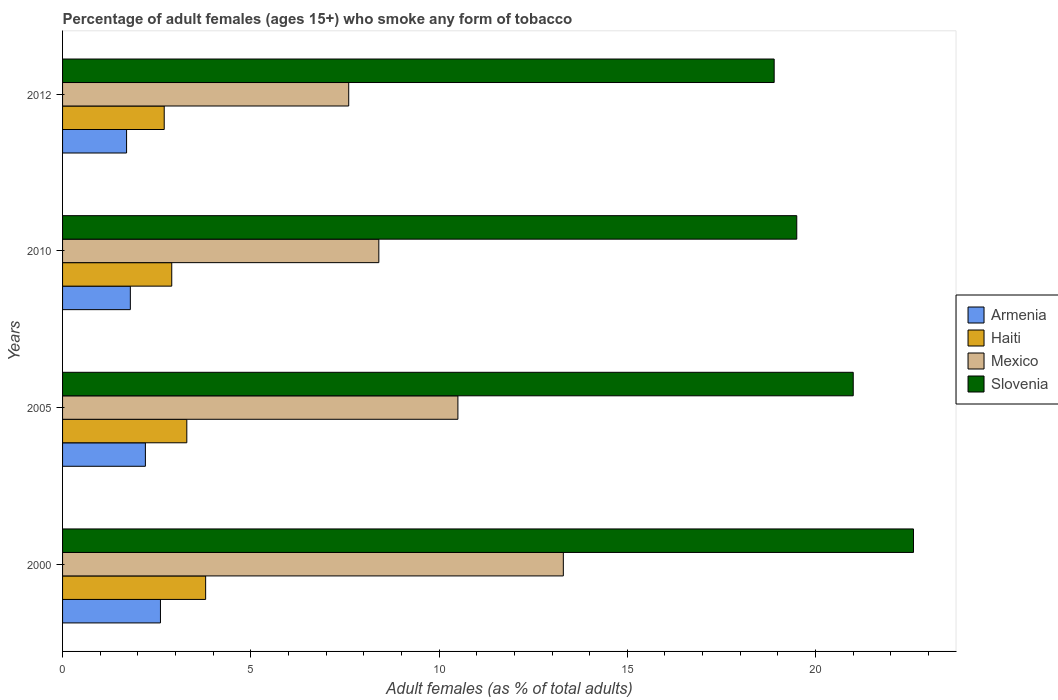How many groups of bars are there?
Provide a short and direct response. 4. How many bars are there on the 3rd tick from the top?
Offer a very short reply. 4. What is the label of the 4th group of bars from the top?
Offer a terse response. 2000. In how many cases, is the number of bars for a given year not equal to the number of legend labels?
Make the answer very short. 0. What is the percentage of adult females who smoke in Slovenia in 2005?
Ensure brevity in your answer.  21. Across all years, what is the minimum percentage of adult females who smoke in Armenia?
Provide a short and direct response. 1.7. What is the total percentage of adult females who smoke in Mexico in the graph?
Provide a short and direct response. 39.8. What is the average percentage of adult females who smoke in Armenia per year?
Offer a terse response. 2.08. In the year 2005, what is the difference between the percentage of adult females who smoke in Armenia and percentage of adult females who smoke in Haiti?
Keep it short and to the point. -1.1. What is the ratio of the percentage of adult females who smoke in Slovenia in 2000 to that in 2010?
Ensure brevity in your answer.  1.16. Is the percentage of adult females who smoke in Slovenia in 2000 less than that in 2005?
Provide a succinct answer. No. Is the difference between the percentage of adult females who smoke in Armenia in 2000 and 2005 greater than the difference between the percentage of adult females who smoke in Haiti in 2000 and 2005?
Your answer should be very brief. No. What is the difference between the highest and the second highest percentage of adult females who smoke in Armenia?
Your answer should be very brief. 0.4. What is the difference between the highest and the lowest percentage of adult females who smoke in Mexico?
Offer a terse response. 5.7. Is the sum of the percentage of adult females who smoke in Mexico in 2005 and 2012 greater than the maximum percentage of adult females who smoke in Slovenia across all years?
Offer a very short reply. No. What does the 4th bar from the top in 2012 represents?
Give a very brief answer. Armenia. Is it the case that in every year, the sum of the percentage of adult females who smoke in Haiti and percentage of adult females who smoke in Slovenia is greater than the percentage of adult females who smoke in Armenia?
Offer a terse response. Yes. How many years are there in the graph?
Make the answer very short. 4. Are the values on the major ticks of X-axis written in scientific E-notation?
Your response must be concise. No. Does the graph contain any zero values?
Offer a terse response. No. How many legend labels are there?
Keep it short and to the point. 4. What is the title of the graph?
Offer a very short reply. Percentage of adult females (ages 15+) who smoke any form of tobacco. What is the label or title of the X-axis?
Your response must be concise. Adult females (as % of total adults). What is the Adult females (as % of total adults) in Haiti in 2000?
Offer a terse response. 3.8. What is the Adult females (as % of total adults) of Mexico in 2000?
Ensure brevity in your answer.  13.3. What is the Adult females (as % of total adults) in Slovenia in 2000?
Offer a terse response. 22.6. What is the Adult females (as % of total adults) in Armenia in 2010?
Your response must be concise. 1.8. What is the Adult females (as % of total adults) in Haiti in 2010?
Ensure brevity in your answer.  2.9. What is the Adult females (as % of total adults) in Armenia in 2012?
Keep it short and to the point. 1.7. What is the Adult females (as % of total adults) in Mexico in 2012?
Your response must be concise. 7.6. What is the Adult females (as % of total adults) in Slovenia in 2012?
Give a very brief answer. 18.9. Across all years, what is the maximum Adult females (as % of total adults) of Armenia?
Make the answer very short. 2.6. Across all years, what is the maximum Adult females (as % of total adults) in Haiti?
Offer a terse response. 3.8. Across all years, what is the maximum Adult females (as % of total adults) of Slovenia?
Your response must be concise. 22.6. Across all years, what is the minimum Adult females (as % of total adults) in Haiti?
Provide a succinct answer. 2.7. Across all years, what is the minimum Adult females (as % of total adults) in Mexico?
Offer a terse response. 7.6. What is the total Adult females (as % of total adults) in Armenia in the graph?
Keep it short and to the point. 8.3. What is the total Adult females (as % of total adults) in Haiti in the graph?
Give a very brief answer. 12.7. What is the total Adult females (as % of total adults) of Mexico in the graph?
Keep it short and to the point. 39.8. What is the total Adult females (as % of total adults) of Slovenia in the graph?
Your answer should be compact. 82. What is the difference between the Adult females (as % of total adults) in Slovenia in 2000 and that in 2005?
Make the answer very short. 1.6. What is the difference between the Adult females (as % of total adults) of Haiti in 2000 and that in 2010?
Offer a very short reply. 0.9. What is the difference between the Adult females (as % of total adults) of Mexico in 2000 and that in 2010?
Keep it short and to the point. 4.9. What is the difference between the Adult females (as % of total adults) in Slovenia in 2000 and that in 2010?
Offer a very short reply. 3.1. What is the difference between the Adult females (as % of total adults) in Slovenia in 2000 and that in 2012?
Provide a short and direct response. 3.7. What is the difference between the Adult females (as % of total adults) of Armenia in 2005 and that in 2010?
Your answer should be very brief. 0.4. What is the difference between the Adult females (as % of total adults) of Slovenia in 2005 and that in 2010?
Offer a terse response. 1.5. What is the difference between the Adult females (as % of total adults) in Haiti in 2005 and that in 2012?
Your answer should be compact. 0.6. What is the difference between the Adult females (as % of total adults) of Armenia in 2010 and that in 2012?
Give a very brief answer. 0.1. What is the difference between the Adult females (as % of total adults) of Haiti in 2010 and that in 2012?
Your answer should be very brief. 0.2. What is the difference between the Adult females (as % of total adults) of Slovenia in 2010 and that in 2012?
Provide a succinct answer. 0.6. What is the difference between the Adult females (as % of total adults) in Armenia in 2000 and the Adult females (as % of total adults) in Haiti in 2005?
Make the answer very short. -0.7. What is the difference between the Adult females (as % of total adults) of Armenia in 2000 and the Adult females (as % of total adults) of Mexico in 2005?
Your answer should be very brief. -7.9. What is the difference between the Adult females (as % of total adults) of Armenia in 2000 and the Adult females (as % of total adults) of Slovenia in 2005?
Offer a very short reply. -18.4. What is the difference between the Adult females (as % of total adults) of Haiti in 2000 and the Adult females (as % of total adults) of Mexico in 2005?
Keep it short and to the point. -6.7. What is the difference between the Adult females (as % of total adults) of Haiti in 2000 and the Adult females (as % of total adults) of Slovenia in 2005?
Make the answer very short. -17.2. What is the difference between the Adult females (as % of total adults) of Mexico in 2000 and the Adult females (as % of total adults) of Slovenia in 2005?
Offer a terse response. -7.7. What is the difference between the Adult females (as % of total adults) in Armenia in 2000 and the Adult females (as % of total adults) in Slovenia in 2010?
Your response must be concise. -16.9. What is the difference between the Adult females (as % of total adults) of Haiti in 2000 and the Adult females (as % of total adults) of Slovenia in 2010?
Provide a succinct answer. -15.7. What is the difference between the Adult females (as % of total adults) in Armenia in 2000 and the Adult females (as % of total adults) in Slovenia in 2012?
Ensure brevity in your answer.  -16.3. What is the difference between the Adult females (as % of total adults) in Haiti in 2000 and the Adult females (as % of total adults) in Mexico in 2012?
Ensure brevity in your answer.  -3.8. What is the difference between the Adult females (as % of total adults) in Haiti in 2000 and the Adult females (as % of total adults) in Slovenia in 2012?
Offer a very short reply. -15.1. What is the difference between the Adult females (as % of total adults) of Mexico in 2000 and the Adult females (as % of total adults) of Slovenia in 2012?
Provide a short and direct response. -5.6. What is the difference between the Adult females (as % of total adults) of Armenia in 2005 and the Adult females (as % of total adults) of Mexico in 2010?
Offer a very short reply. -6.2. What is the difference between the Adult females (as % of total adults) of Armenia in 2005 and the Adult females (as % of total adults) of Slovenia in 2010?
Your response must be concise. -17.3. What is the difference between the Adult females (as % of total adults) of Haiti in 2005 and the Adult females (as % of total adults) of Mexico in 2010?
Ensure brevity in your answer.  -5.1. What is the difference between the Adult females (as % of total adults) of Haiti in 2005 and the Adult females (as % of total adults) of Slovenia in 2010?
Offer a very short reply. -16.2. What is the difference between the Adult females (as % of total adults) of Armenia in 2005 and the Adult females (as % of total adults) of Haiti in 2012?
Provide a short and direct response. -0.5. What is the difference between the Adult females (as % of total adults) in Armenia in 2005 and the Adult females (as % of total adults) in Slovenia in 2012?
Your answer should be very brief. -16.7. What is the difference between the Adult females (as % of total adults) of Haiti in 2005 and the Adult females (as % of total adults) of Slovenia in 2012?
Offer a very short reply. -15.6. What is the difference between the Adult females (as % of total adults) in Mexico in 2005 and the Adult females (as % of total adults) in Slovenia in 2012?
Your response must be concise. -8.4. What is the difference between the Adult females (as % of total adults) of Armenia in 2010 and the Adult females (as % of total adults) of Mexico in 2012?
Your answer should be compact. -5.8. What is the difference between the Adult females (as % of total adults) of Armenia in 2010 and the Adult females (as % of total adults) of Slovenia in 2012?
Your response must be concise. -17.1. What is the average Adult females (as % of total adults) in Armenia per year?
Your answer should be very brief. 2.08. What is the average Adult females (as % of total adults) of Haiti per year?
Make the answer very short. 3.17. What is the average Adult females (as % of total adults) of Mexico per year?
Your response must be concise. 9.95. What is the average Adult females (as % of total adults) in Slovenia per year?
Provide a succinct answer. 20.5. In the year 2000, what is the difference between the Adult females (as % of total adults) in Armenia and Adult females (as % of total adults) in Slovenia?
Your response must be concise. -20. In the year 2000, what is the difference between the Adult females (as % of total adults) of Haiti and Adult females (as % of total adults) of Slovenia?
Your answer should be compact. -18.8. In the year 2005, what is the difference between the Adult females (as % of total adults) in Armenia and Adult females (as % of total adults) in Haiti?
Make the answer very short. -1.1. In the year 2005, what is the difference between the Adult females (as % of total adults) in Armenia and Adult females (as % of total adults) in Slovenia?
Offer a terse response. -18.8. In the year 2005, what is the difference between the Adult females (as % of total adults) of Haiti and Adult females (as % of total adults) of Slovenia?
Your response must be concise. -17.7. In the year 2005, what is the difference between the Adult females (as % of total adults) in Mexico and Adult females (as % of total adults) in Slovenia?
Provide a succinct answer. -10.5. In the year 2010, what is the difference between the Adult females (as % of total adults) in Armenia and Adult females (as % of total adults) in Mexico?
Provide a short and direct response. -6.6. In the year 2010, what is the difference between the Adult females (as % of total adults) in Armenia and Adult females (as % of total adults) in Slovenia?
Provide a short and direct response. -17.7. In the year 2010, what is the difference between the Adult females (as % of total adults) of Haiti and Adult females (as % of total adults) of Mexico?
Give a very brief answer. -5.5. In the year 2010, what is the difference between the Adult females (as % of total adults) of Haiti and Adult females (as % of total adults) of Slovenia?
Give a very brief answer. -16.6. In the year 2010, what is the difference between the Adult females (as % of total adults) of Mexico and Adult females (as % of total adults) of Slovenia?
Give a very brief answer. -11.1. In the year 2012, what is the difference between the Adult females (as % of total adults) of Armenia and Adult females (as % of total adults) of Slovenia?
Offer a terse response. -17.2. In the year 2012, what is the difference between the Adult females (as % of total adults) in Haiti and Adult females (as % of total adults) in Slovenia?
Your answer should be compact. -16.2. What is the ratio of the Adult females (as % of total adults) in Armenia in 2000 to that in 2005?
Offer a very short reply. 1.18. What is the ratio of the Adult females (as % of total adults) of Haiti in 2000 to that in 2005?
Offer a terse response. 1.15. What is the ratio of the Adult females (as % of total adults) in Mexico in 2000 to that in 2005?
Your response must be concise. 1.27. What is the ratio of the Adult females (as % of total adults) in Slovenia in 2000 to that in 2005?
Keep it short and to the point. 1.08. What is the ratio of the Adult females (as % of total adults) of Armenia in 2000 to that in 2010?
Offer a very short reply. 1.44. What is the ratio of the Adult females (as % of total adults) of Haiti in 2000 to that in 2010?
Make the answer very short. 1.31. What is the ratio of the Adult females (as % of total adults) of Mexico in 2000 to that in 2010?
Keep it short and to the point. 1.58. What is the ratio of the Adult females (as % of total adults) in Slovenia in 2000 to that in 2010?
Your answer should be compact. 1.16. What is the ratio of the Adult females (as % of total adults) in Armenia in 2000 to that in 2012?
Your answer should be very brief. 1.53. What is the ratio of the Adult females (as % of total adults) of Haiti in 2000 to that in 2012?
Provide a short and direct response. 1.41. What is the ratio of the Adult females (as % of total adults) of Slovenia in 2000 to that in 2012?
Offer a terse response. 1.2. What is the ratio of the Adult females (as % of total adults) of Armenia in 2005 to that in 2010?
Make the answer very short. 1.22. What is the ratio of the Adult females (as % of total adults) in Haiti in 2005 to that in 2010?
Give a very brief answer. 1.14. What is the ratio of the Adult females (as % of total adults) of Slovenia in 2005 to that in 2010?
Keep it short and to the point. 1.08. What is the ratio of the Adult females (as % of total adults) in Armenia in 2005 to that in 2012?
Your answer should be compact. 1.29. What is the ratio of the Adult females (as % of total adults) of Haiti in 2005 to that in 2012?
Provide a short and direct response. 1.22. What is the ratio of the Adult females (as % of total adults) of Mexico in 2005 to that in 2012?
Keep it short and to the point. 1.38. What is the ratio of the Adult females (as % of total adults) in Armenia in 2010 to that in 2012?
Provide a short and direct response. 1.06. What is the ratio of the Adult females (as % of total adults) of Haiti in 2010 to that in 2012?
Your response must be concise. 1.07. What is the ratio of the Adult females (as % of total adults) in Mexico in 2010 to that in 2012?
Your answer should be very brief. 1.11. What is the ratio of the Adult females (as % of total adults) in Slovenia in 2010 to that in 2012?
Make the answer very short. 1.03. What is the difference between the highest and the second highest Adult females (as % of total adults) of Haiti?
Your answer should be very brief. 0.5. What is the difference between the highest and the second highest Adult females (as % of total adults) in Mexico?
Give a very brief answer. 2.8. What is the difference between the highest and the lowest Adult females (as % of total adults) in Haiti?
Make the answer very short. 1.1. What is the difference between the highest and the lowest Adult females (as % of total adults) of Slovenia?
Make the answer very short. 3.7. 